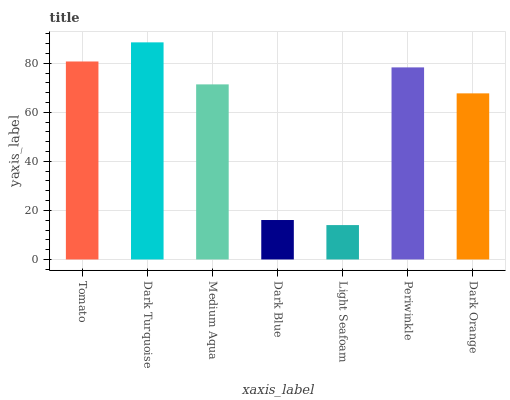Is Light Seafoam the minimum?
Answer yes or no. Yes. Is Dark Turquoise the maximum?
Answer yes or no. Yes. Is Medium Aqua the minimum?
Answer yes or no. No. Is Medium Aqua the maximum?
Answer yes or no. No. Is Dark Turquoise greater than Medium Aqua?
Answer yes or no. Yes. Is Medium Aqua less than Dark Turquoise?
Answer yes or no. Yes. Is Medium Aqua greater than Dark Turquoise?
Answer yes or no. No. Is Dark Turquoise less than Medium Aqua?
Answer yes or no. No. Is Medium Aqua the high median?
Answer yes or no. Yes. Is Medium Aqua the low median?
Answer yes or no. Yes. Is Dark Turquoise the high median?
Answer yes or no. No. Is Periwinkle the low median?
Answer yes or no. No. 